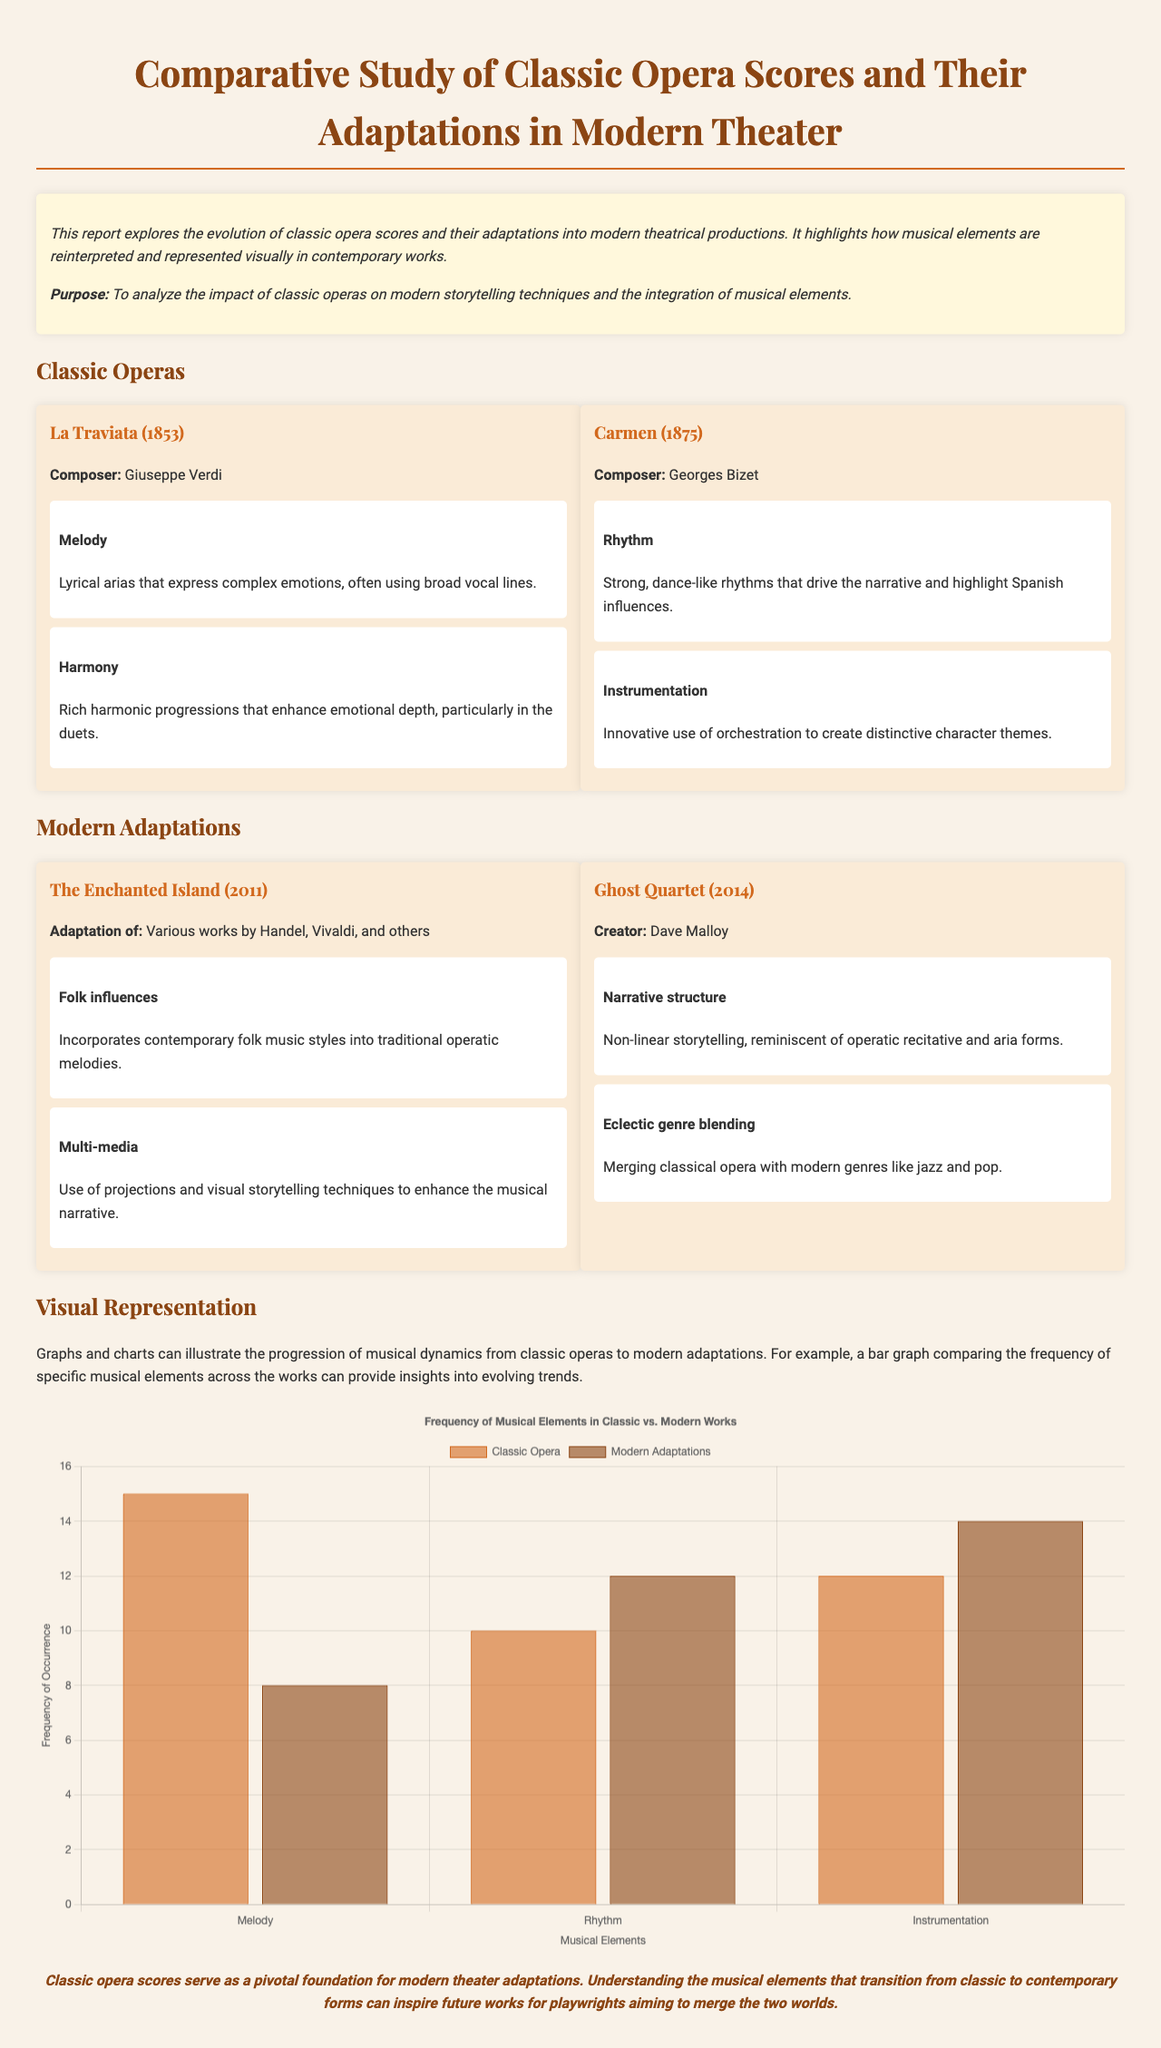What is the publication year of La Traviata? La Traviata was first performed in 1853, as mentioned in the document.
Answer: 1853 Who composed Carmen? The document states that Carmen was composed by Georges Bizet.
Answer: Georges Bizet What type of storytelling technique is highlighted in The Enchanted Island? The document notes that The Enchanted Island incorporates contemporary folk music styles into its operatic melodies.
Answer: Folk influences How many musical elements are compared in the chart? The chart compares three musical elements: Melody, Rhythm, and Instrumentation.
Answer: Three Which modern adaptation is created by Dave Malloy? The report mentions Ghost Quartet as the adaptation created by Dave Malloy.
Answer: Ghost Quartet What is the main purpose of this report? The purpose of the report is to analyze the impact of classic operas on modern storytelling techniques and the integration of musical elements.
Answer: To analyze the impact of classic operas What is illustrated through graphs and charts in the document? Graphs and charts illustrate the progression of musical dynamics from classic operas to modern adaptations.
Answer: The progression of musical dynamics What is a noted characteristic of the rhythm in Carmen? The document describes the rhythm in Carmen as strong and dance-like, highlighting its Spanish influences.
Answer: Strong, dance-like rhythms What is emphasized in the conclusion about classic opera scores? The conclusion states that classic opera scores serve as a pivotal foundation for modern theater adaptations.
Answer: Pivotal foundation 